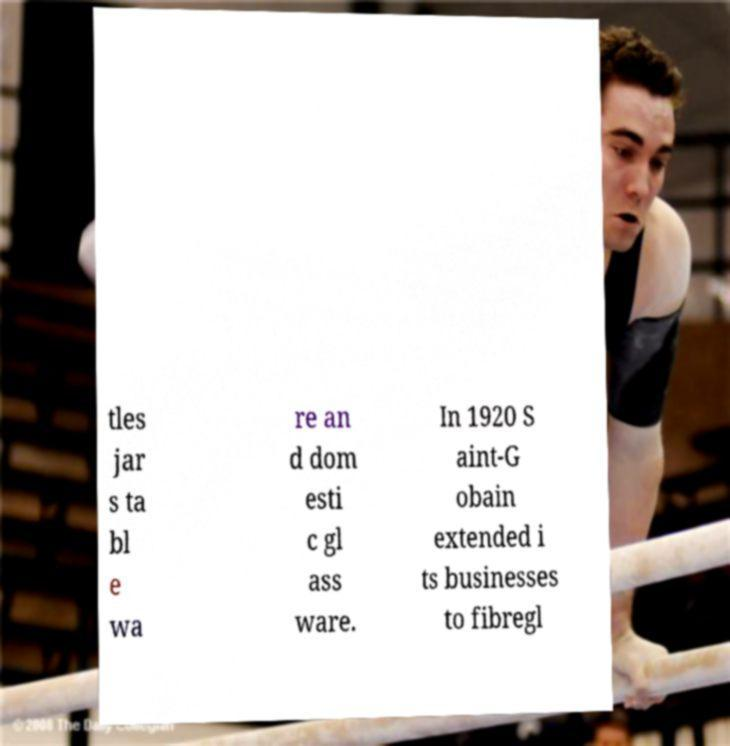What messages or text are displayed in this image? I need them in a readable, typed format. tles jar s ta bl e wa re an d dom esti c gl ass ware. In 1920 S aint-G obain extended i ts businesses to fibregl 